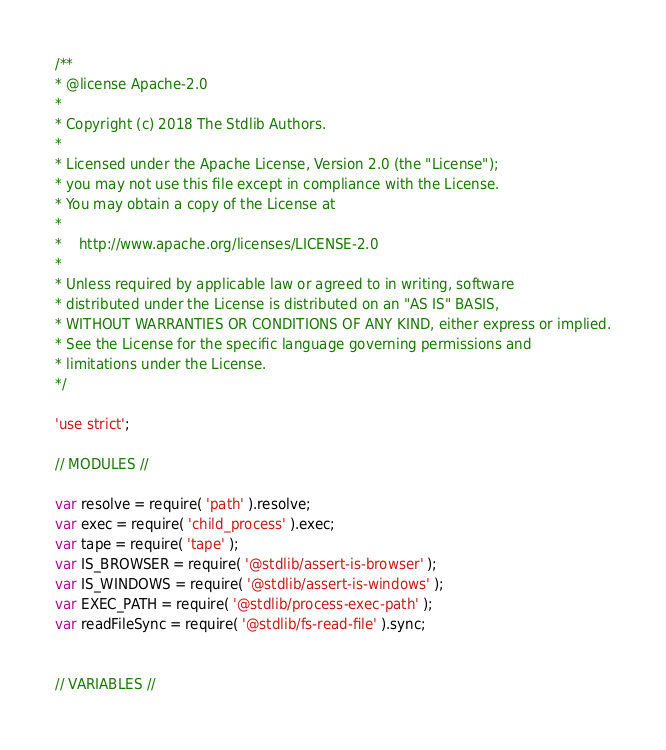<code> <loc_0><loc_0><loc_500><loc_500><_JavaScript_>/**
* @license Apache-2.0
*
* Copyright (c) 2018 The Stdlib Authors.
*
* Licensed under the Apache License, Version 2.0 (the "License");
* you may not use this file except in compliance with the License.
* You may obtain a copy of the License at
*
*    http://www.apache.org/licenses/LICENSE-2.0
*
* Unless required by applicable law or agreed to in writing, software
* distributed under the License is distributed on an "AS IS" BASIS,
* WITHOUT WARRANTIES OR CONDITIONS OF ANY KIND, either express or implied.
* See the License for the specific language governing permissions and
* limitations under the License.
*/

'use strict';

// MODULES //

var resolve = require( 'path' ).resolve;
var exec = require( 'child_process' ).exec;
var tape = require( 'tape' );
var IS_BROWSER = require( '@stdlib/assert-is-browser' );
var IS_WINDOWS = require( '@stdlib/assert-is-windows' );
var EXEC_PATH = require( '@stdlib/process-exec-path' );
var readFileSync = require( '@stdlib/fs-read-file' ).sync;


// VARIABLES //
</code> 